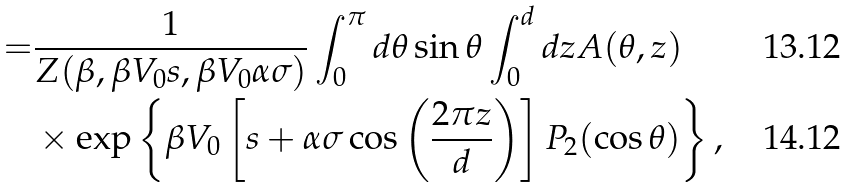<formula> <loc_0><loc_0><loc_500><loc_500>= & \frac { 1 } { Z ( \beta , \beta V _ { 0 } s , \beta V _ { 0 } \alpha \sigma ) } \int _ { 0 } ^ { \pi } d \theta \sin \theta \int _ { 0 } ^ { d } d z A ( \theta , z ) \\ & \times \exp \left \{ \beta V _ { 0 } \left [ s + \alpha \sigma \cos \left ( \frac { 2 \pi z } { d } \right ) \right ] P _ { 2 } ( \cos \theta ) \right \} ,</formula> 